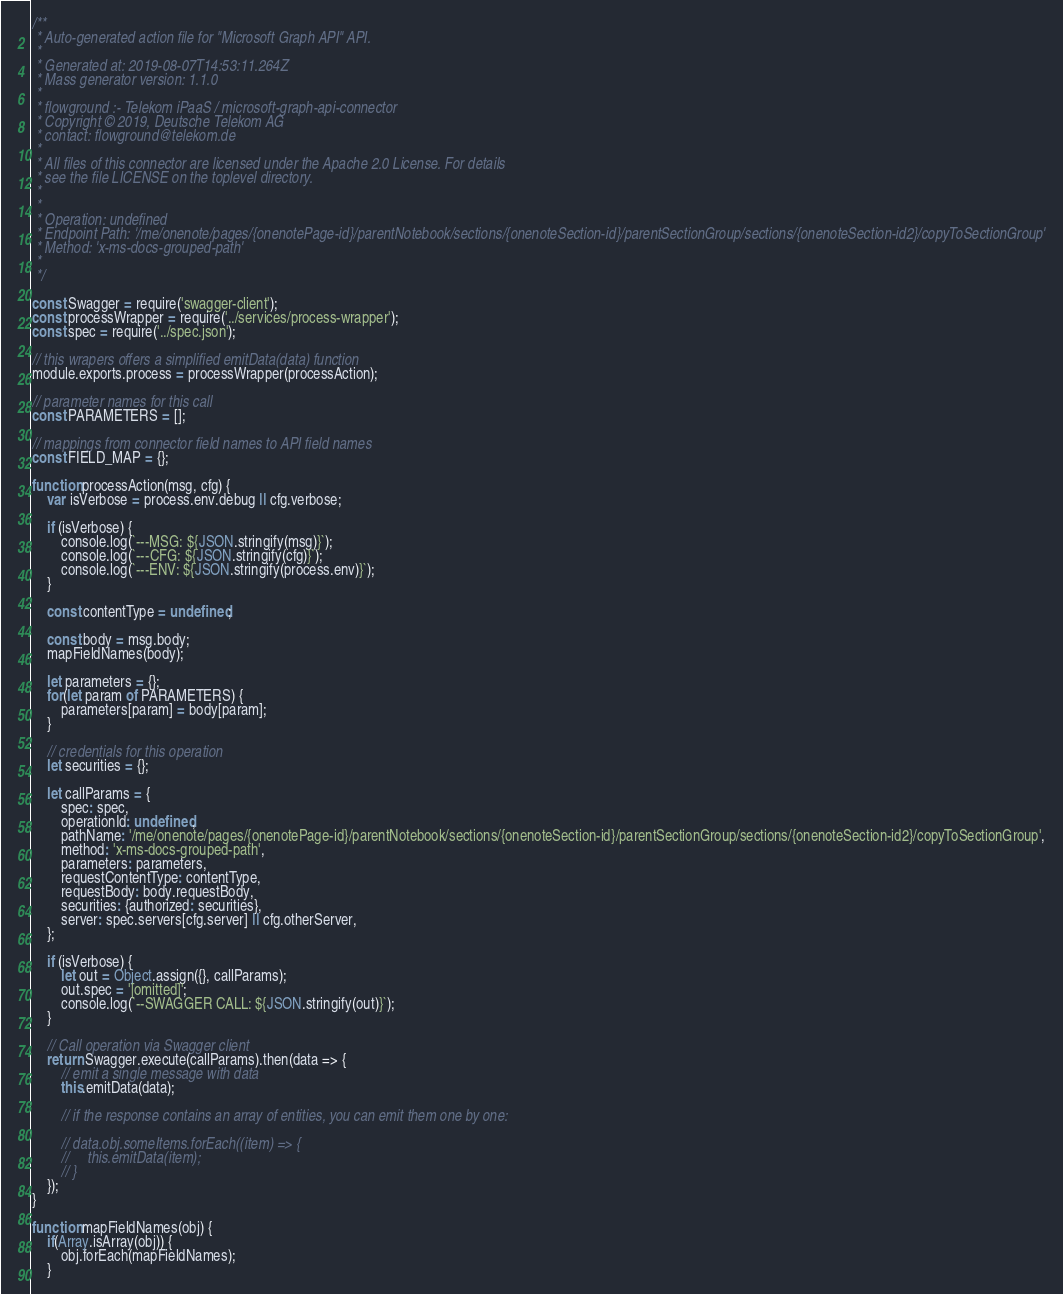Convert code to text. <code><loc_0><loc_0><loc_500><loc_500><_JavaScript_>/**
 * Auto-generated action file for "Microsoft Graph API" API.
 *
 * Generated at: 2019-08-07T14:53:11.264Z
 * Mass generator version: 1.1.0
 *
 * flowground :- Telekom iPaaS / microsoft-graph-api-connector
 * Copyright © 2019, Deutsche Telekom AG
 * contact: flowground@telekom.de
 *
 * All files of this connector are licensed under the Apache 2.0 License. For details
 * see the file LICENSE on the toplevel directory.
 *
 *
 * Operation: undefined
 * Endpoint Path: '/me/onenote/pages/{onenotePage-id}/parentNotebook/sections/{onenoteSection-id}/parentSectionGroup/sections/{onenoteSection-id2}/copyToSectionGroup'
 * Method: 'x-ms-docs-grouped-path'
 *
 */

const Swagger = require('swagger-client');
const processWrapper = require('../services/process-wrapper');
const spec = require('../spec.json');

// this wrapers offers a simplified emitData(data) function
module.exports.process = processWrapper(processAction);

// parameter names for this call
const PARAMETERS = [];

// mappings from connector field names to API field names
const FIELD_MAP = {};

function processAction(msg, cfg) {
    var isVerbose = process.env.debug || cfg.verbose;

    if (isVerbose) {
        console.log(`---MSG: ${JSON.stringify(msg)}`);
        console.log(`---CFG: ${JSON.stringify(cfg)}`);
        console.log(`---ENV: ${JSON.stringify(process.env)}`);
    }

    const contentType = undefined;

    const body = msg.body;
    mapFieldNames(body);

    let parameters = {};
    for(let param of PARAMETERS) {
        parameters[param] = body[param];
    }

    // credentials for this operation
    let securities = {};

    let callParams = {
        spec: spec,
        operationId: undefined,
        pathName: '/me/onenote/pages/{onenotePage-id}/parentNotebook/sections/{onenoteSection-id}/parentSectionGroup/sections/{onenoteSection-id2}/copyToSectionGroup',
        method: 'x-ms-docs-grouped-path',
        parameters: parameters,
        requestContentType: contentType,
        requestBody: body.requestBody,
        securities: {authorized: securities},
        server: spec.servers[cfg.server] || cfg.otherServer,
    };

    if (isVerbose) {
        let out = Object.assign({}, callParams);
        out.spec = '[omitted]';
        console.log(`--SWAGGER CALL: ${JSON.stringify(out)}`);
    }

    // Call operation via Swagger client
    return Swagger.execute(callParams).then(data => {
        // emit a single message with data
        this.emitData(data);

        // if the response contains an array of entities, you can emit them one by one:

        // data.obj.someItems.forEach((item) => {
        //     this.emitData(item);
        // }
    });
}

function mapFieldNames(obj) {
    if(Array.isArray(obj)) {
        obj.forEach(mapFieldNames);
    }</code> 